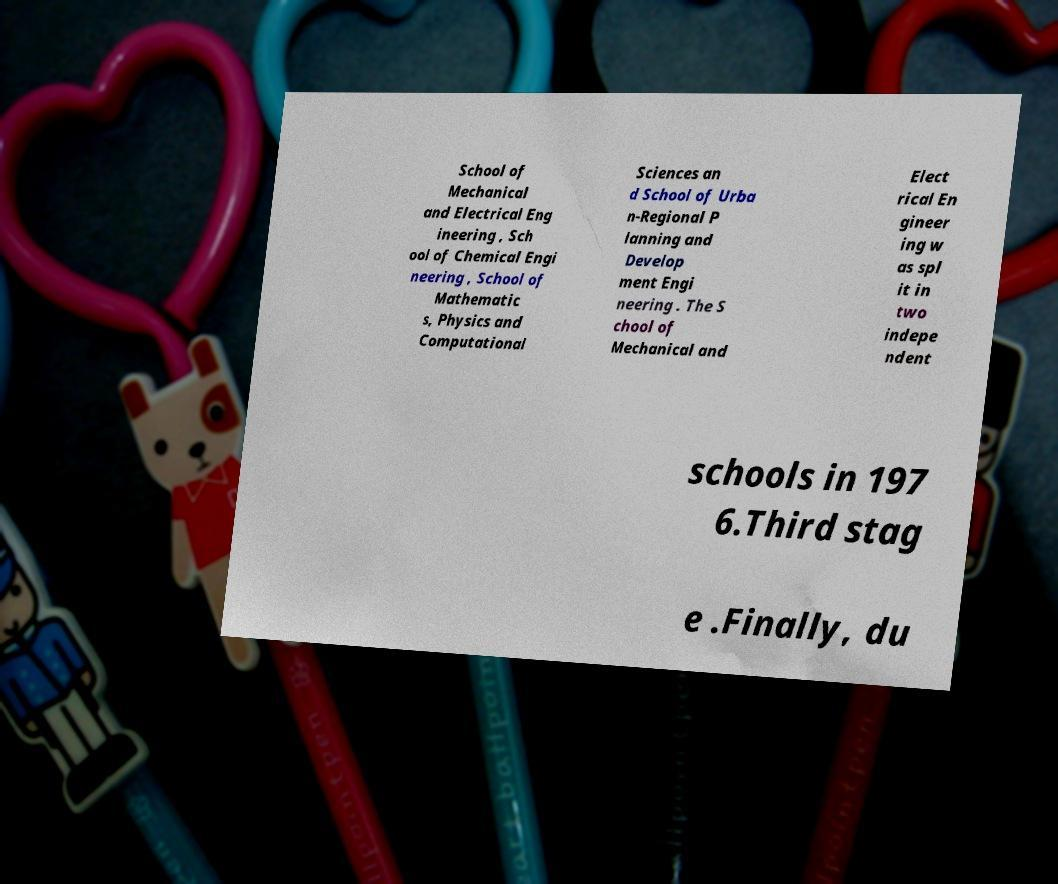Please identify and transcribe the text found in this image. School of Mechanical and Electrical Eng ineering , Sch ool of Chemical Engi neering , School of Mathematic s, Physics and Computational Sciences an d School of Urba n-Regional P lanning and Develop ment Engi neering . The S chool of Mechanical and Elect rical En gineer ing w as spl it in two indepe ndent schools in 197 6.Third stag e .Finally, du 